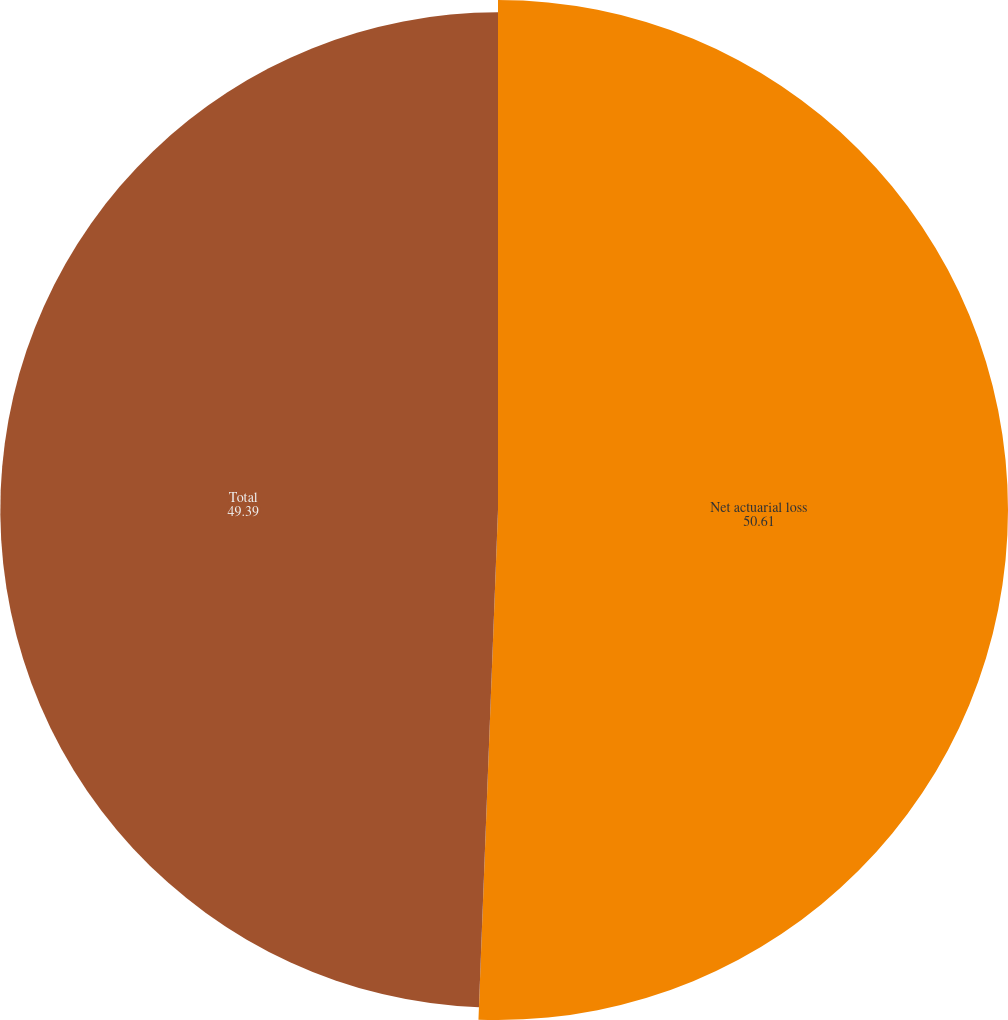Convert chart to OTSL. <chart><loc_0><loc_0><loc_500><loc_500><pie_chart><fcel>Net actuarial loss<fcel>Total<nl><fcel>50.61%<fcel>49.39%<nl></chart> 